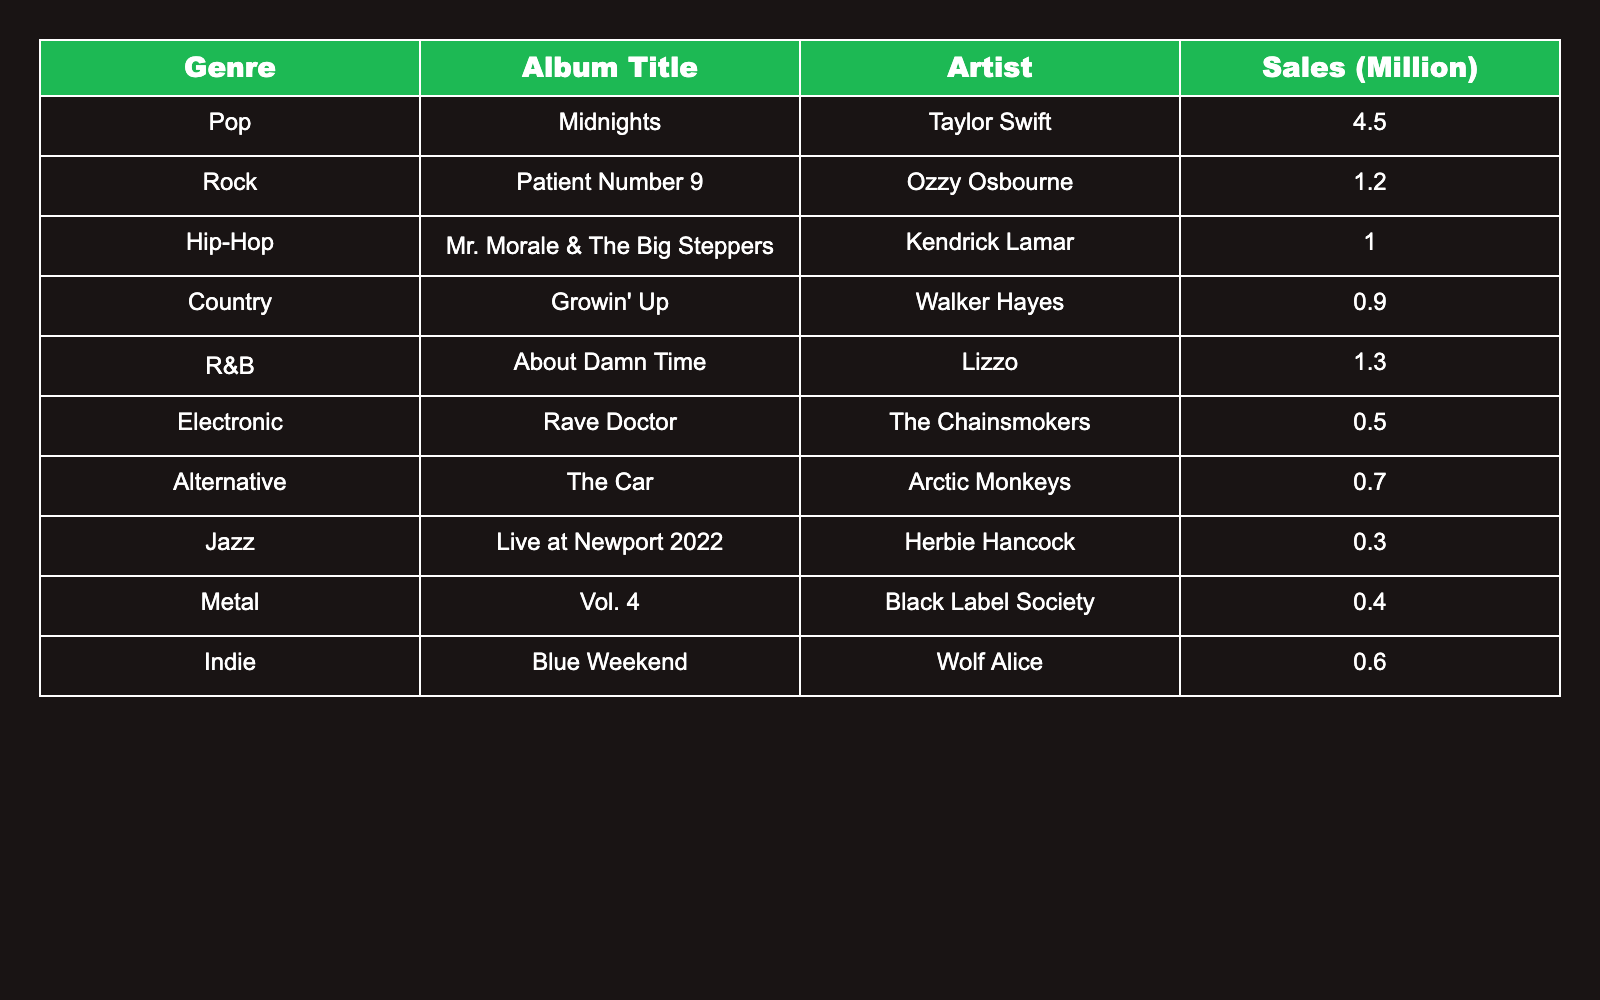What is the best-selling album in the Pop genre? According to the table, "Midnights" by Taylor Swift has the highest sales figure of 4.5 million in the Pop genre.
Answer: 4.5 million Which genre has the lowest sales figures? From the table, the Jazz genre has "Live at Newport 2022" by Herbie Hancock with sales of 0.3 million, which is the lowest among all genres.
Answer: Jazz How many million albums were sold by the Indie genre? The Indie genre features "Blue Weekend" by Wolf Alice, which sold 0.6 million albums, as indicated in the table.
Answer: 0.6 million What is the total sales of albums in the Country and R&B genres? The sales for Country ("Growin' Up" by Walker Hayes) is 0.9 million and for R&B ("About Damn Time" by Lizzo) is 1.3 million. The total is 0.9 + 1.3 = 2.2 million.
Answer: 2.2 million Is the sales figure of the Metal genre greater than that of the Hip-Hop genre? The Metal genre "Vol. 4" by Black Label Society has sales of 0.4 million and the Hip-Hop genre "Mr. Morale & The Big Steppers" by Kendrick Lamar has sales of 1.0 million. Since 0.4 million is less than 1.0 million, the statement is false.
Answer: No What is the average sales figure for all genres combined? To find the average, first sum the sales figures: 4.5 + 1.2 + 1.0 + 0.9 + 1.3 + 0.5 + 0.7 + 0.3 + 0.4 + 0.6 = 12.4 million. There are 10 albums, so the average is 12.4 / 10 = 1.24 million.
Answer: 1.24 million Which genre has greater sales: Electronic or Alternative? The Electronic genre "Rave Doctor" sold 0.5 million, while the Alternative genre "The Car" sold 0.7 million. Since 0.7 million is greater than 0.5 million, Alternative has greater sales.
Answer: Alternative How many more million albums did the Pop genre sell compared to the Country genre? The Pop genre "Midnights" sold 4.5 million, and the Country genre "Growin' Up" sold 0.9 million. The difference is 4.5 - 0.9 = 3.6 million.
Answer: 3.6 million Which artist has the highest sales in the table? The artist with the highest sales is Taylor Swift with "Midnights," which sold 4.5 million albums, as seen in the table.
Answer: Taylor Swift What percentage of the total sales is represented by the sales of the R&B genre? The total sales is 12.4 million. The R&B genre sales is 1.3 million. The percentage is (1.3 / 12.4) * 100 = approximately 10.48%.
Answer: Approximately 10.48% 